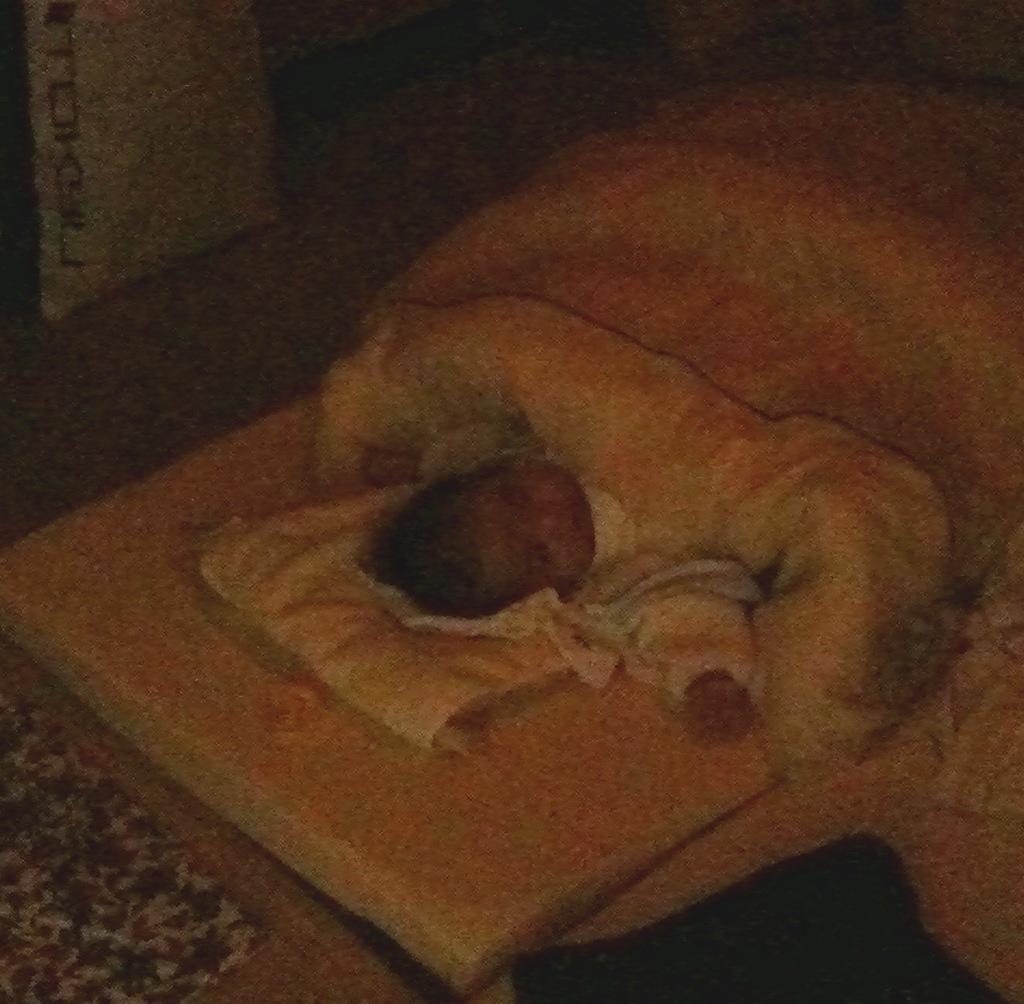In one or two sentences, can you explain what this image depicts? In this picture we can see a baby, clothes, some objects and in the background it is blurry. 